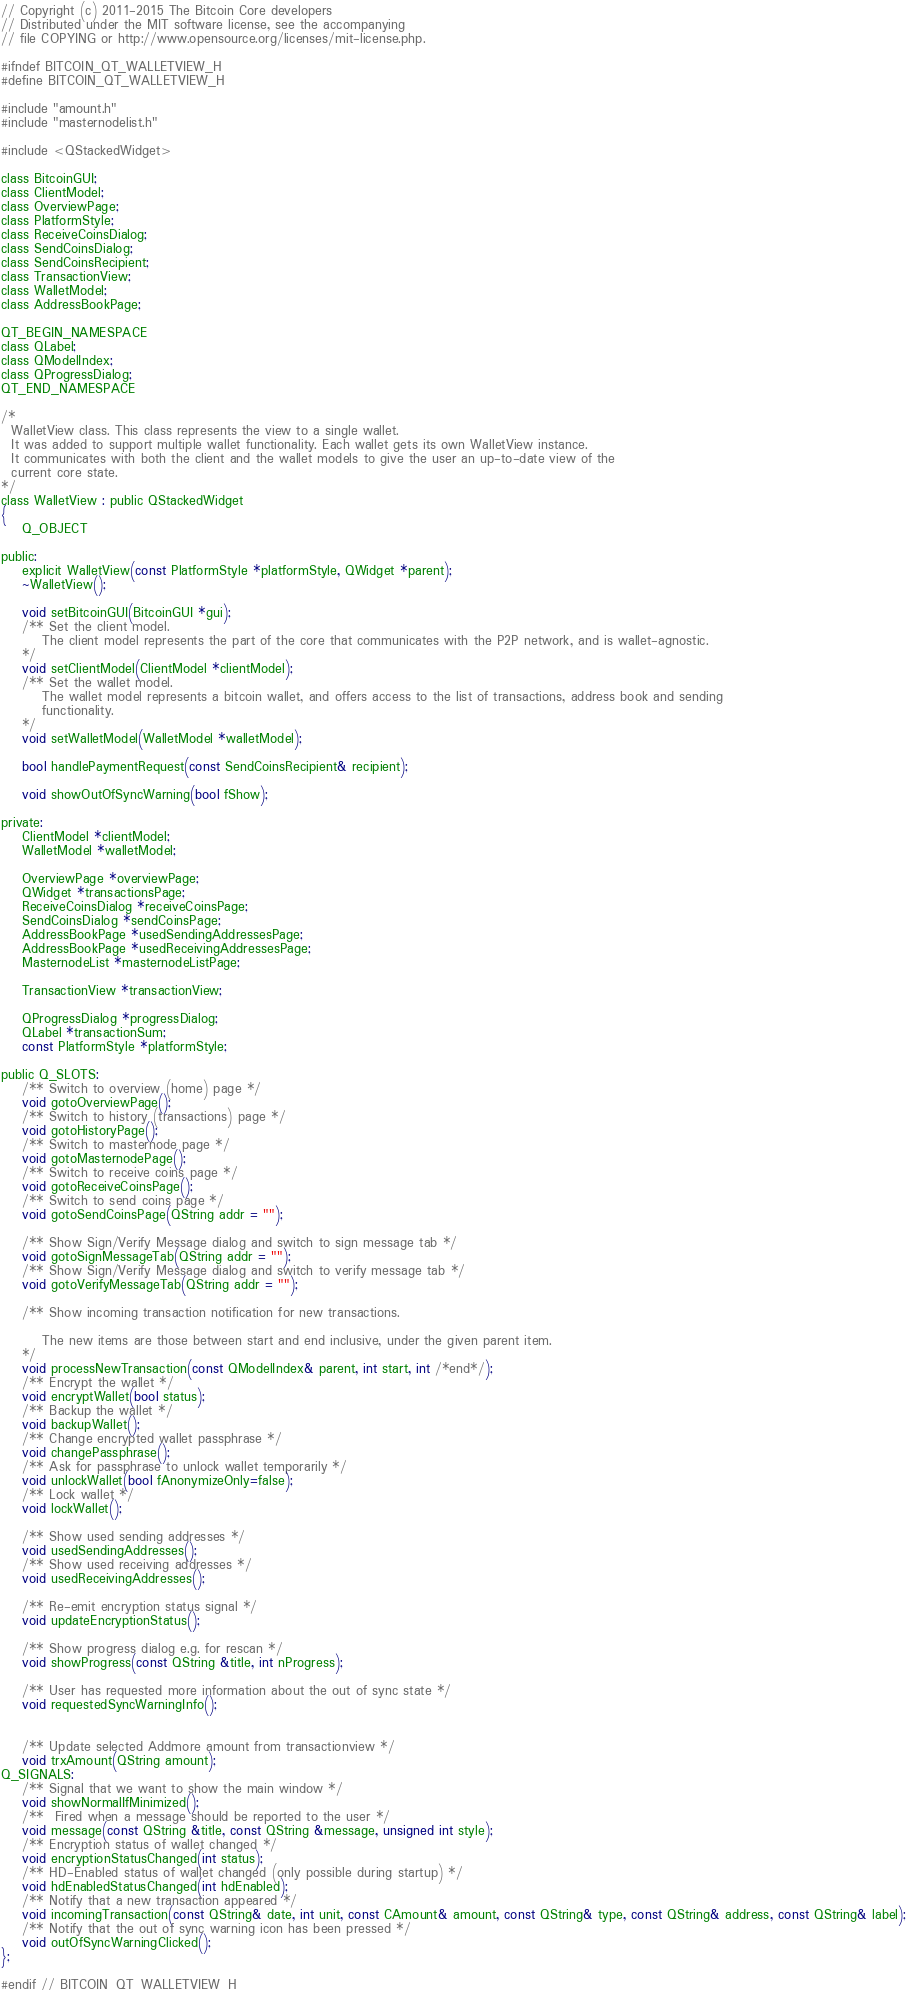Convert code to text. <code><loc_0><loc_0><loc_500><loc_500><_C_>// Copyright (c) 2011-2015 The Bitcoin Core developers
// Distributed under the MIT software license, see the accompanying
// file COPYING or http://www.opensource.org/licenses/mit-license.php.

#ifndef BITCOIN_QT_WALLETVIEW_H
#define BITCOIN_QT_WALLETVIEW_H

#include "amount.h"
#include "masternodelist.h"

#include <QStackedWidget>

class BitcoinGUI;
class ClientModel;
class OverviewPage;
class PlatformStyle;
class ReceiveCoinsDialog;
class SendCoinsDialog;
class SendCoinsRecipient;
class TransactionView;
class WalletModel;
class AddressBookPage;

QT_BEGIN_NAMESPACE
class QLabel;
class QModelIndex;
class QProgressDialog;
QT_END_NAMESPACE

/*
  WalletView class. This class represents the view to a single wallet.
  It was added to support multiple wallet functionality. Each wallet gets its own WalletView instance.
  It communicates with both the client and the wallet models to give the user an up-to-date view of the
  current core state.
*/
class WalletView : public QStackedWidget
{
    Q_OBJECT

public:
    explicit WalletView(const PlatformStyle *platformStyle, QWidget *parent);
    ~WalletView();

    void setBitcoinGUI(BitcoinGUI *gui);
    /** Set the client model.
        The client model represents the part of the core that communicates with the P2P network, and is wallet-agnostic.
    */
    void setClientModel(ClientModel *clientModel);
    /** Set the wallet model.
        The wallet model represents a bitcoin wallet, and offers access to the list of transactions, address book and sending
        functionality.
    */
    void setWalletModel(WalletModel *walletModel);

    bool handlePaymentRequest(const SendCoinsRecipient& recipient);

    void showOutOfSyncWarning(bool fShow);

private:
    ClientModel *clientModel;
    WalletModel *walletModel;

    OverviewPage *overviewPage;
    QWidget *transactionsPage;
    ReceiveCoinsDialog *receiveCoinsPage;
    SendCoinsDialog *sendCoinsPage;
    AddressBookPage *usedSendingAddressesPage;
    AddressBookPage *usedReceivingAddressesPage;
    MasternodeList *masternodeListPage;

    TransactionView *transactionView;

    QProgressDialog *progressDialog;
    QLabel *transactionSum;
    const PlatformStyle *platformStyle;

public Q_SLOTS:
    /** Switch to overview (home) page */
    void gotoOverviewPage();
    /** Switch to history (transactions) page */
    void gotoHistoryPage();
    /** Switch to masternode page */
    void gotoMasternodePage();
    /** Switch to receive coins page */
    void gotoReceiveCoinsPage();
    /** Switch to send coins page */
    void gotoSendCoinsPage(QString addr = "");

    /** Show Sign/Verify Message dialog and switch to sign message tab */
    void gotoSignMessageTab(QString addr = "");
    /** Show Sign/Verify Message dialog and switch to verify message tab */
    void gotoVerifyMessageTab(QString addr = "");

    /** Show incoming transaction notification for new transactions.

        The new items are those between start and end inclusive, under the given parent item.
    */
    void processNewTransaction(const QModelIndex& parent, int start, int /*end*/);
    /** Encrypt the wallet */
    void encryptWallet(bool status);
    /** Backup the wallet */
    void backupWallet();
    /** Change encrypted wallet passphrase */
    void changePassphrase();
    /** Ask for passphrase to unlock wallet temporarily */
    void unlockWallet(bool fAnonymizeOnly=false);
    /** Lock wallet */
    void lockWallet();

    /** Show used sending addresses */
    void usedSendingAddresses();
    /** Show used receiving addresses */
    void usedReceivingAddresses();

    /** Re-emit encryption status signal */
    void updateEncryptionStatus();

    /** Show progress dialog e.g. for rescan */
    void showProgress(const QString &title, int nProgress);

    /** User has requested more information about the out of sync state */
    void requestedSyncWarningInfo();


    /** Update selected Addmore amount from transactionview */
    void trxAmount(QString amount);
Q_SIGNALS:
    /** Signal that we want to show the main window */
    void showNormalIfMinimized();
    /**  Fired when a message should be reported to the user */
    void message(const QString &title, const QString &message, unsigned int style);
    /** Encryption status of wallet changed */
    void encryptionStatusChanged(int status);
    /** HD-Enabled status of wallet changed (only possible during startup) */
    void hdEnabledStatusChanged(int hdEnabled);
    /** Notify that a new transaction appeared */
    void incomingTransaction(const QString& date, int unit, const CAmount& amount, const QString& type, const QString& address, const QString& label);
    /** Notify that the out of sync warning icon has been pressed */
    void outOfSyncWarningClicked();
};

#endif // BITCOIN_QT_WALLETVIEW_H
</code> 